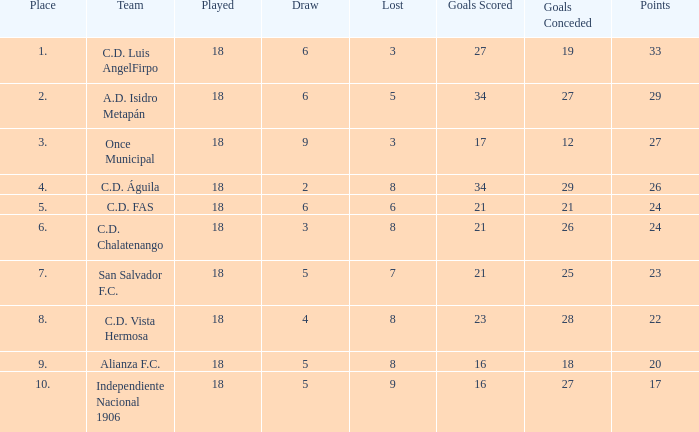What is the site at which once municipal has a lost greater than three? None. 